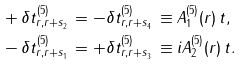Convert formula to latex. <formula><loc_0><loc_0><loc_500><loc_500>& + \delta t ^ { ( 5 ) } _ { r , r + s ^ { \ } _ { 2 } } = - \delta t ^ { ( 5 ) } _ { r , r + s ^ { \ } _ { 4 } } \equiv A ^ { ( 5 ) } _ { 1 } ( r ) \, t , \\ & - \delta t ^ { ( 5 ) } _ { r , r + s ^ { \ } _ { 1 } } = + \delta t ^ { ( 5 ) } _ { r , r + s ^ { \ } _ { 3 } } \equiv i A ^ { ( 5 ) } _ { 2 } ( r ) \, t .</formula> 